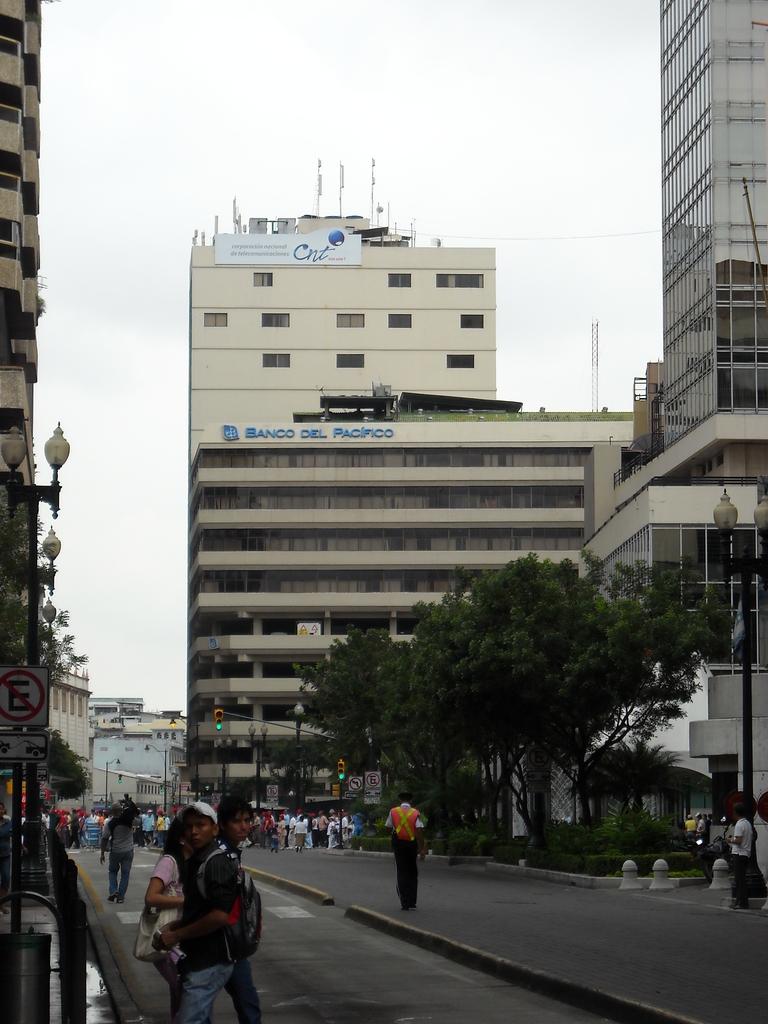What kind of establishment is this?
Provide a short and direct response. Bank. 